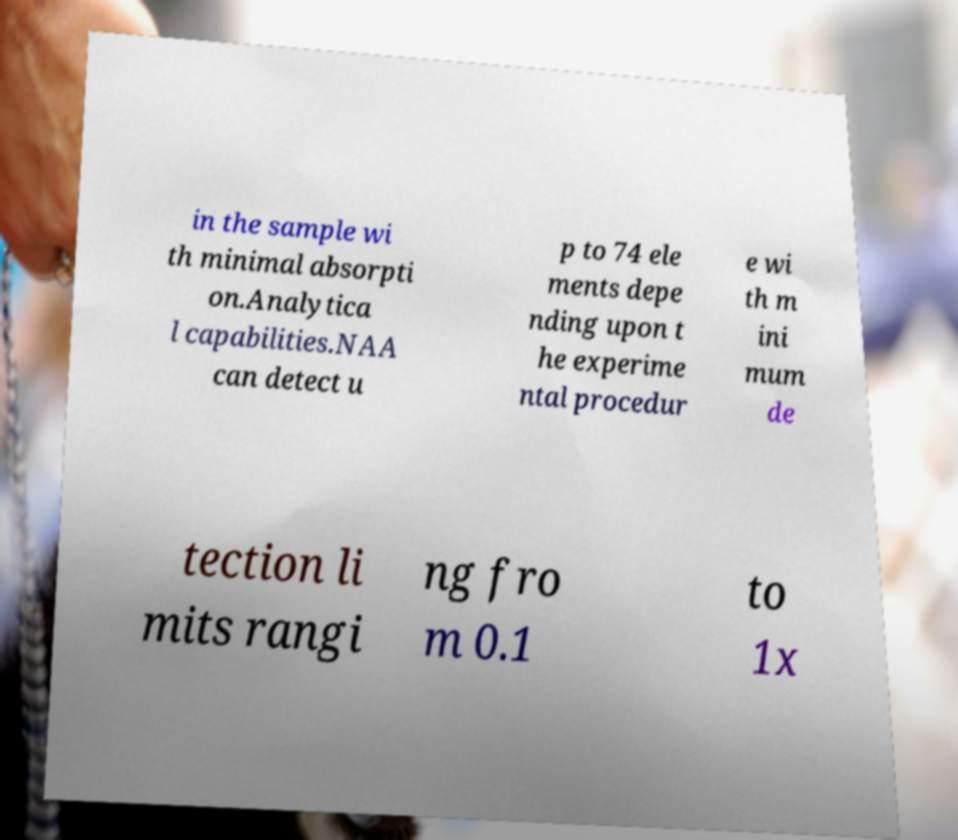I need the written content from this picture converted into text. Can you do that? in the sample wi th minimal absorpti on.Analytica l capabilities.NAA can detect u p to 74 ele ments depe nding upon t he experime ntal procedur e wi th m ini mum de tection li mits rangi ng fro m 0.1 to 1x 